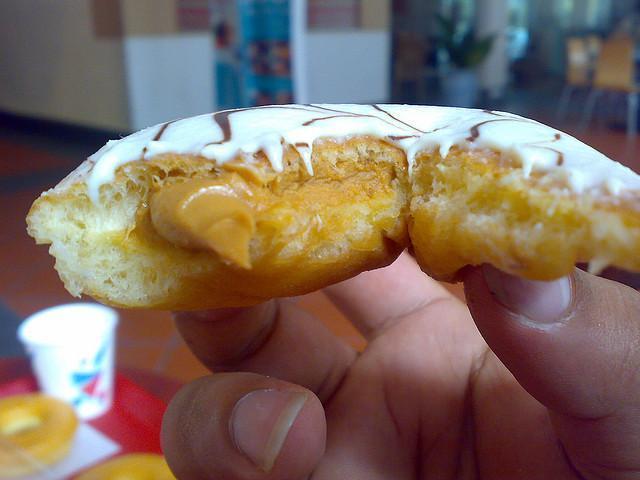How many donuts are there?
Give a very brief answer. 2. How many cups are visible?
Give a very brief answer. 1. 